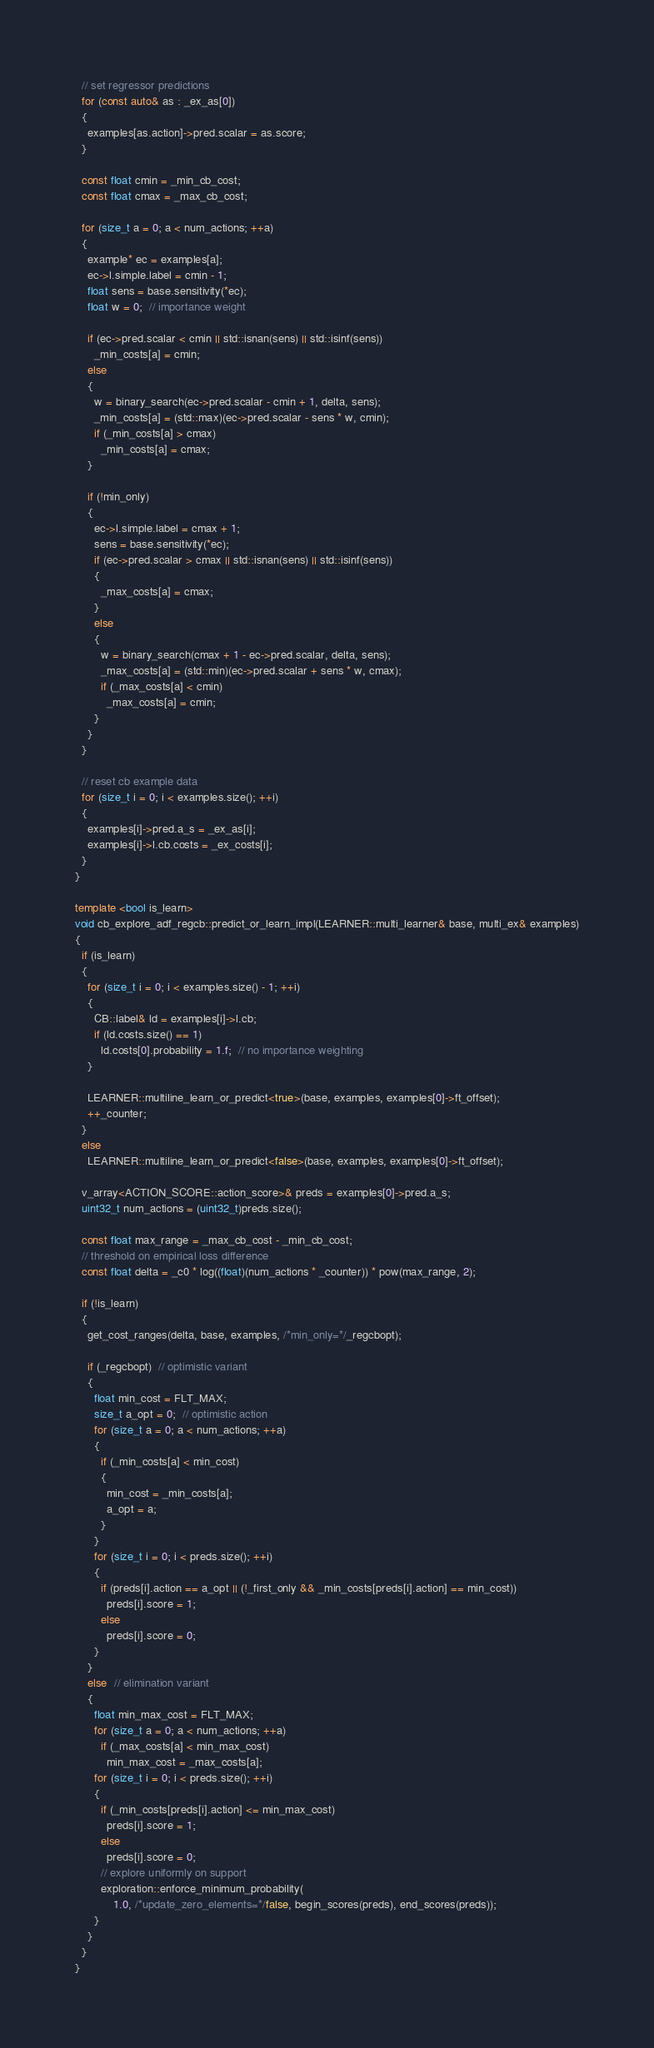Convert code to text. <code><loc_0><loc_0><loc_500><loc_500><_C++_>  // set regressor predictions
  for (const auto& as : _ex_as[0])
  {
    examples[as.action]->pred.scalar = as.score;
  }

  const float cmin = _min_cb_cost;
  const float cmax = _max_cb_cost;

  for (size_t a = 0; a < num_actions; ++a)
  {
    example* ec = examples[a];
    ec->l.simple.label = cmin - 1;
    float sens = base.sensitivity(*ec);
    float w = 0;  // importance weight

    if (ec->pred.scalar < cmin || std::isnan(sens) || std::isinf(sens))
      _min_costs[a] = cmin;
    else
    {
      w = binary_search(ec->pred.scalar - cmin + 1, delta, sens);
      _min_costs[a] = (std::max)(ec->pred.scalar - sens * w, cmin);
      if (_min_costs[a] > cmax)
        _min_costs[a] = cmax;
    }

    if (!min_only)
    {
      ec->l.simple.label = cmax + 1;
      sens = base.sensitivity(*ec);
      if (ec->pred.scalar > cmax || std::isnan(sens) || std::isinf(sens))
      {
        _max_costs[a] = cmax;
      }
      else
      {
        w = binary_search(cmax + 1 - ec->pred.scalar, delta, sens);
        _max_costs[a] = (std::min)(ec->pred.scalar + sens * w, cmax);
        if (_max_costs[a] < cmin)
          _max_costs[a] = cmin;
      }
    }
  }

  // reset cb example data
  for (size_t i = 0; i < examples.size(); ++i)
  {
    examples[i]->pred.a_s = _ex_as[i];
    examples[i]->l.cb.costs = _ex_costs[i];
  }
}

template <bool is_learn>
void cb_explore_adf_regcb::predict_or_learn_impl(LEARNER::multi_learner& base, multi_ex& examples)
{
  if (is_learn)
  {
    for (size_t i = 0; i < examples.size() - 1; ++i)
    {
      CB::label& ld = examples[i]->l.cb;
      if (ld.costs.size() == 1)
        ld.costs[0].probability = 1.f;  // no importance weighting
    }

    LEARNER::multiline_learn_or_predict<true>(base, examples, examples[0]->ft_offset);
    ++_counter;
  }
  else
    LEARNER::multiline_learn_or_predict<false>(base, examples, examples[0]->ft_offset);

  v_array<ACTION_SCORE::action_score>& preds = examples[0]->pred.a_s;
  uint32_t num_actions = (uint32_t)preds.size();

  const float max_range = _max_cb_cost - _min_cb_cost;
  // threshold on empirical loss difference
  const float delta = _c0 * log((float)(num_actions * _counter)) * pow(max_range, 2);

  if (!is_learn)
  {
    get_cost_ranges(delta, base, examples, /*min_only=*/_regcbopt);

    if (_regcbopt)  // optimistic variant
    {
      float min_cost = FLT_MAX;
      size_t a_opt = 0;  // optimistic action
      for (size_t a = 0; a < num_actions; ++a)
      {
        if (_min_costs[a] < min_cost)
        {
          min_cost = _min_costs[a];
          a_opt = a;
        }
      }
      for (size_t i = 0; i < preds.size(); ++i)
      {
        if (preds[i].action == a_opt || (!_first_only && _min_costs[preds[i].action] == min_cost))
          preds[i].score = 1;
        else
          preds[i].score = 0;
      }
    }
    else  // elimination variant
    {
      float min_max_cost = FLT_MAX;
      for (size_t a = 0; a < num_actions; ++a)
        if (_max_costs[a] < min_max_cost)
          min_max_cost = _max_costs[a];
      for (size_t i = 0; i < preds.size(); ++i)
      {
        if (_min_costs[preds[i].action] <= min_max_cost)
          preds[i].score = 1;
        else
          preds[i].score = 0;
        // explore uniformly on support
        exploration::enforce_minimum_probability(
            1.0, /*update_zero_elements=*/false, begin_scores(preds), end_scores(preds));
      }
    }
  }
}
</code> 